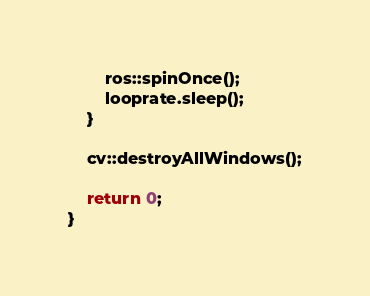<code> <loc_0><loc_0><loc_500><loc_500><_C++_>		ros::spinOnce();
		looprate.sleep();
	}

	cv::destroyAllWindows();

	return 0;
}
</code> 